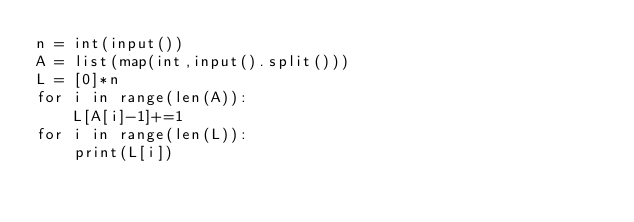Convert code to text. <code><loc_0><loc_0><loc_500><loc_500><_Python_>n = int(input())
A = list(map(int,input().split()))
L = [0]*n
for i in range(len(A)):
    L[A[i]-1]+=1
for i in range(len(L)):
    print(L[i])
</code> 